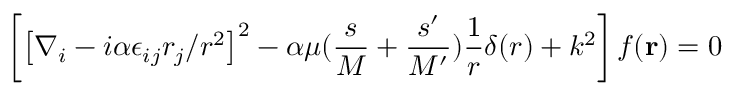Convert formula to latex. <formula><loc_0><loc_0><loc_500><loc_500>\left [ \left [ \nabla _ { i } - i \alpha \epsilon _ { i j } r _ { j } / r ^ { 2 } \right ] ^ { 2 } - \alpha \mu ( { \frac { s } { M } } + { \frac { s ^ { \prime } } { M ^ { \prime } } } ) { \frac { 1 } { r } } \delta ( r ) + k ^ { 2 } \right ] f ( { r } ) = 0</formula> 